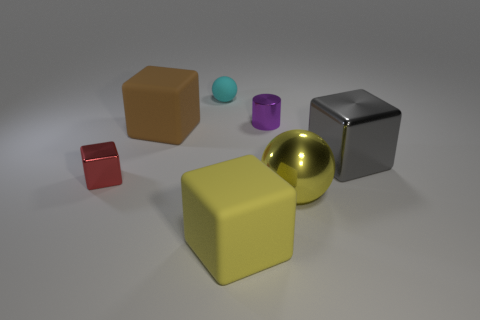Subtract all blue cubes. Subtract all red balls. How many cubes are left? 4 Add 2 small blue metal spheres. How many objects exist? 9 Subtract all blocks. How many objects are left? 3 Add 3 tiny green rubber cubes. How many tiny green rubber cubes exist? 3 Subtract 0 cyan blocks. How many objects are left? 7 Subtract all yellow metal things. Subtract all purple shiny cylinders. How many objects are left? 5 Add 2 large brown rubber blocks. How many large brown rubber blocks are left? 3 